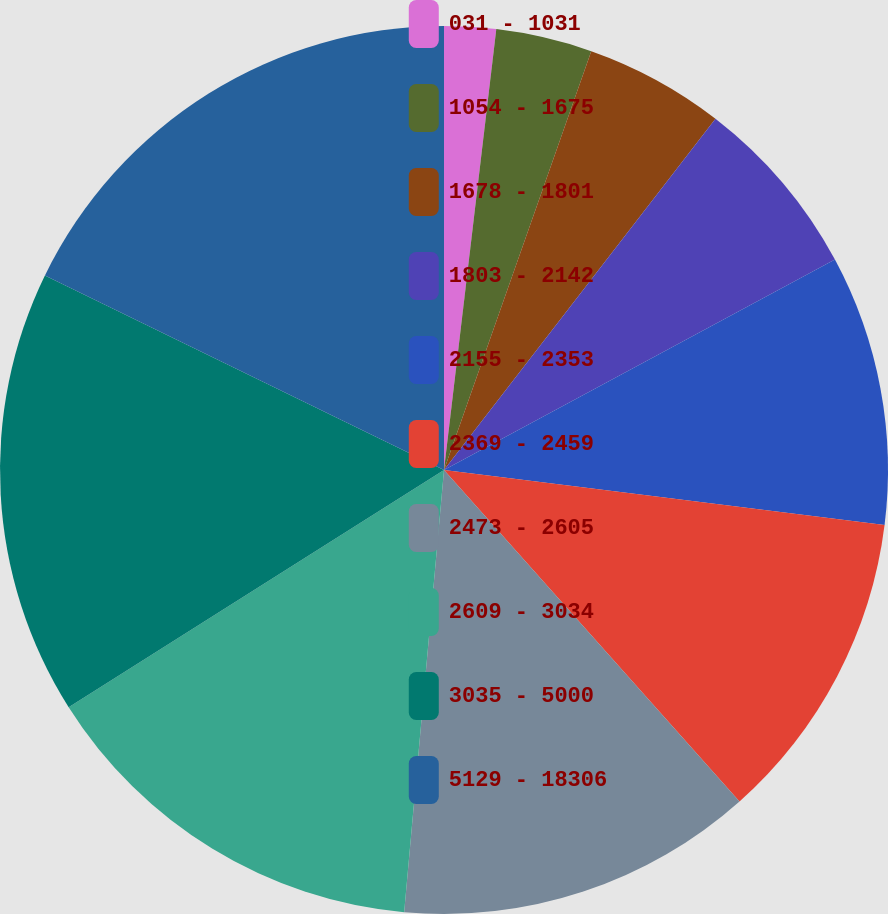Convert chart. <chart><loc_0><loc_0><loc_500><loc_500><pie_chart><fcel>031 - 1031<fcel>1054 - 1675<fcel>1678 - 1801<fcel>1803 - 2142<fcel>2155 - 2353<fcel>2369 - 2459<fcel>2473 - 2605<fcel>2609 - 3034<fcel>3035 - 5000<fcel>5129 - 18306<nl><fcel>1.88%<fcel>3.5%<fcel>5.09%<fcel>6.67%<fcel>9.84%<fcel>11.43%<fcel>13.02%<fcel>14.6%<fcel>16.19%<fcel>17.78%<nl></chart> 